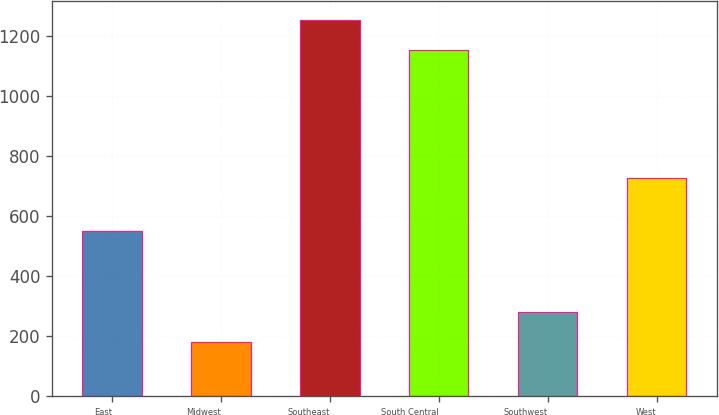<chart> <loc_0><loc_0><loc_500><loc_500><bar_chart><fcel>East<fcel>Midwest<fcel>Southeast<fcel>South Central<fcel>Southwest<fcel>West<nl><fcel>548.6<fcel>179.2<fcel>1251.11<fcel>1151.8<fcel>278.51<fcel>725.3<nl></chart> 